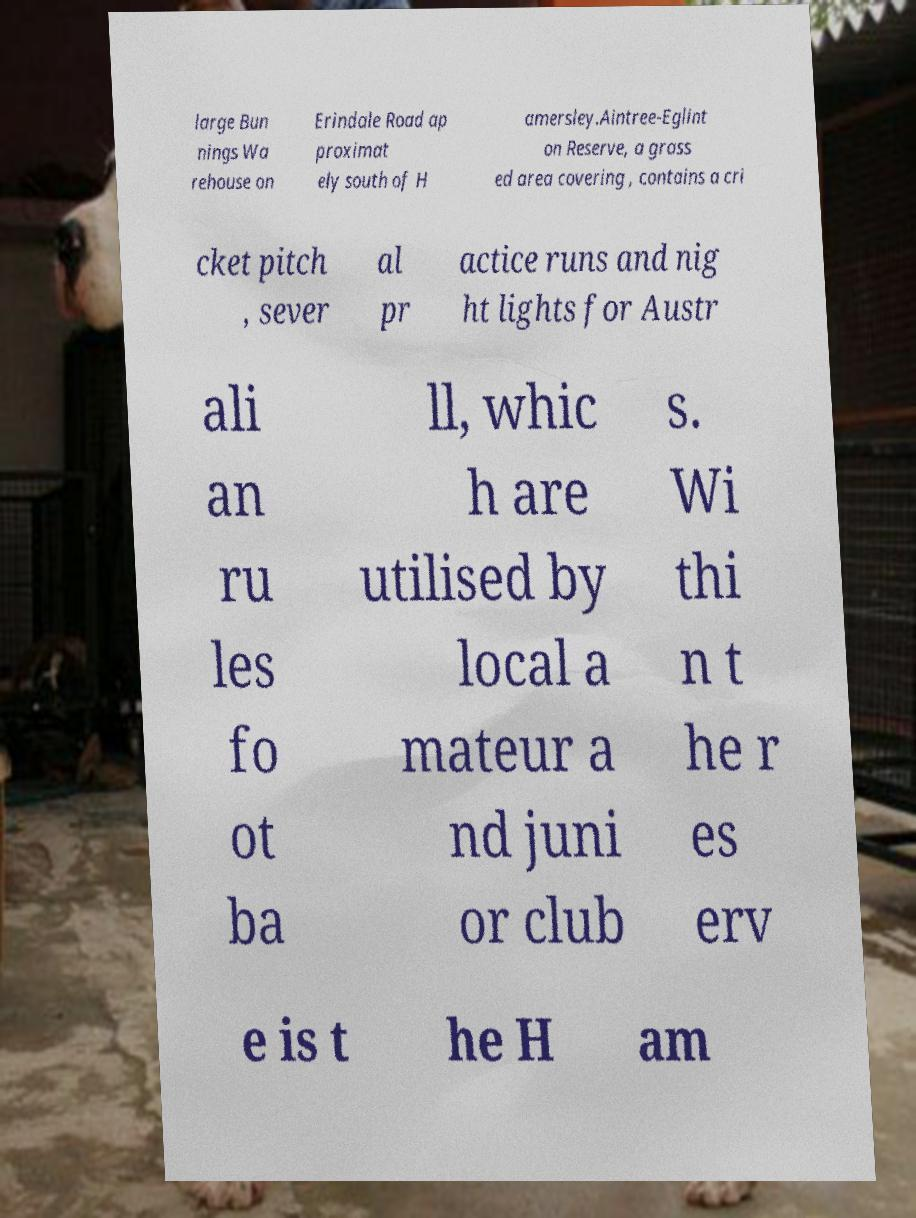Please read and relay the text visible in this image. What does it say? large Bun nings Wa rehouse on Erindale Road ap proximat ely south of H amersley.Aintree-Eglint on Reserve, a grass ed area covering , contains a cri cket pitch , sever al pr actice runs and nig ht lights for Austr ali an ru les fo ot ba ll, whic h are utilised by local a mateur a nd juni or club s. Wi thi n t he r es erv e is t he H am 